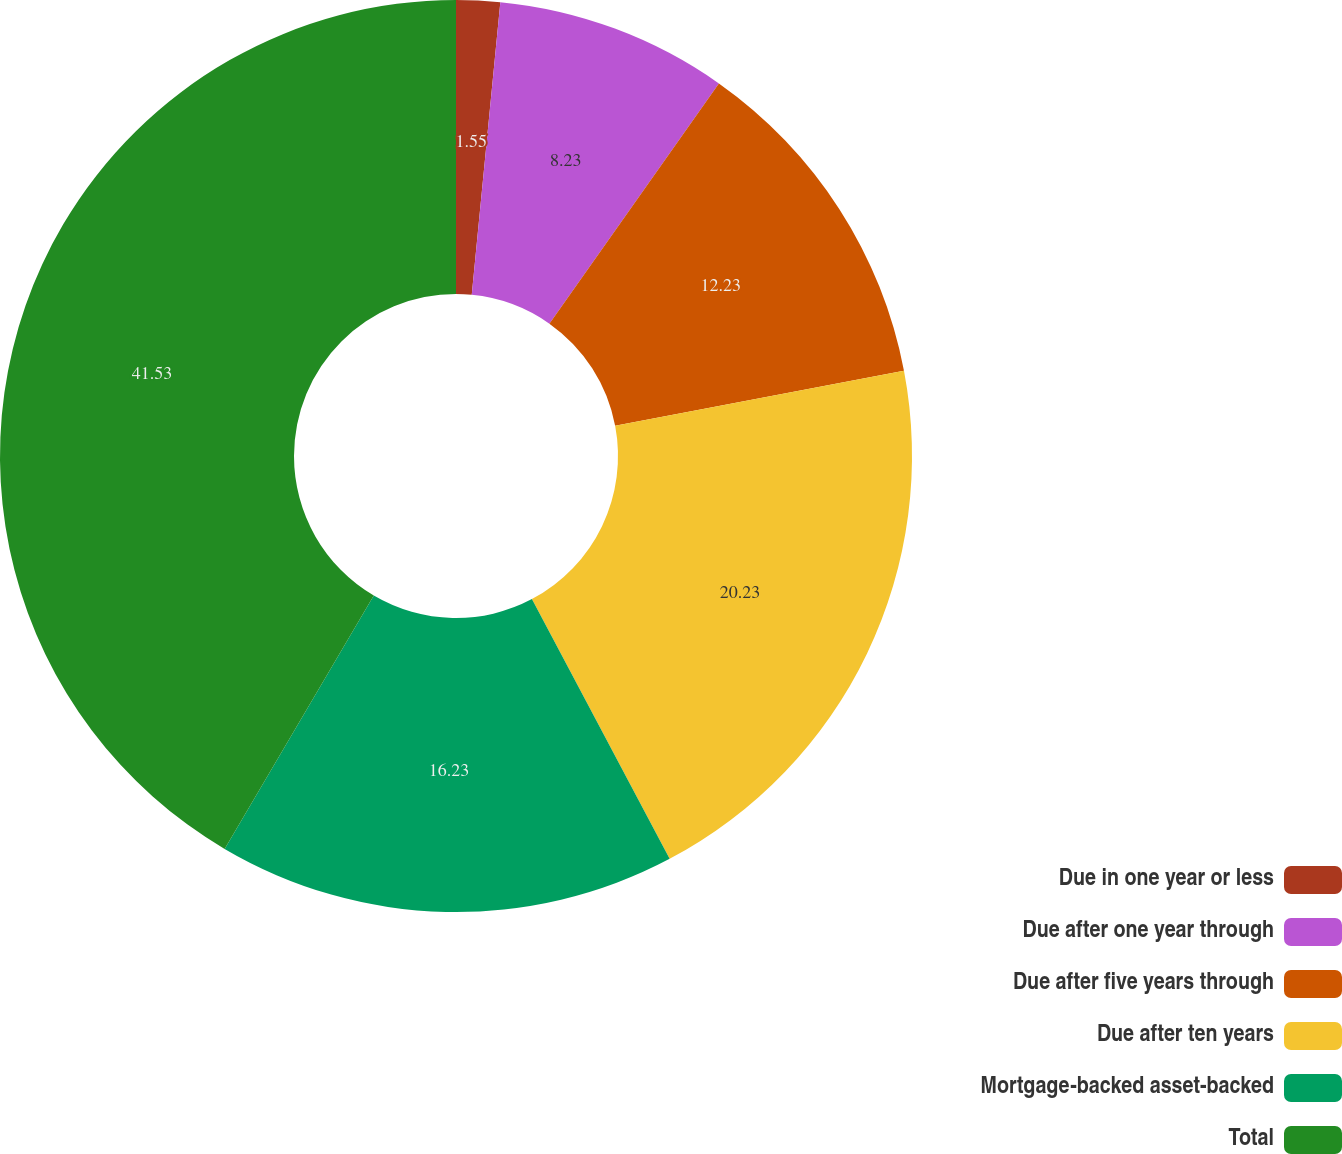Convert chart. <chart><loc_0><loc_0><loc_500><loc_500><pie_chart><fcel>Due in one year or less<fcel>Due after one year through<fcel>Due after five years through<fcel>Due after ten years<fcel>Mortgage-backed asset-backed<fcel>Total<nl><fcel>1.55%<fcel>8.23%<fcel>12.23%<fcel>20.23%<fcel>16.23%<fcel>41.53%<nl></chart> 